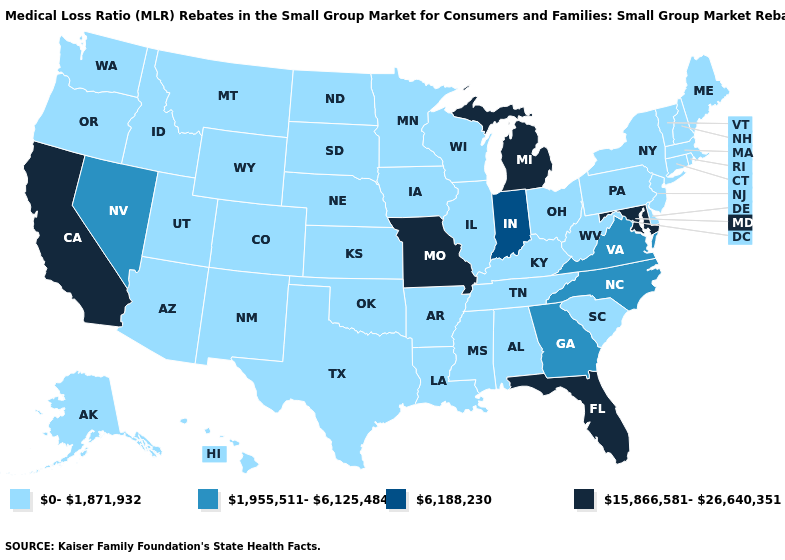What is the value of Vermont?
Be succinct. 0-1,871,932. Does Utah have a higher value than Wyoming?
Keep it brief. No. Does the map have missing data?
Answer briefly. No. How many symbols are there in the legend?
Quick response, please. 4. What is the highest value in the USA?
Write a very short answer. 15,866,581-26,640,351. Is the legend a continuous bar?
Give a very brief answer. No. What is the value of California?
Be succinct. 15,866,581-26,640,351. Does Nevada have the lowest value in the USA?
Give a very brief answer. No. Name the states that have a value in the range 1,955,511-6,125,484?
Answer briefly. Georgia, Nevada, North Carolina, Virginia. What is the highest value in the USA?
Concise answer only. 15,866,581-26,640,351. What is the lowest value in the USA?
Quick response, please. 0-1,871,932. Among the states that border Wyoming , which have the highest value?
Give a very brief answer. Colorado, Idaho, Montana, Nebraska, South Dakota, Utah. What is the lowest value in the MidWest?
Short answer required. 0-1,871,932. 